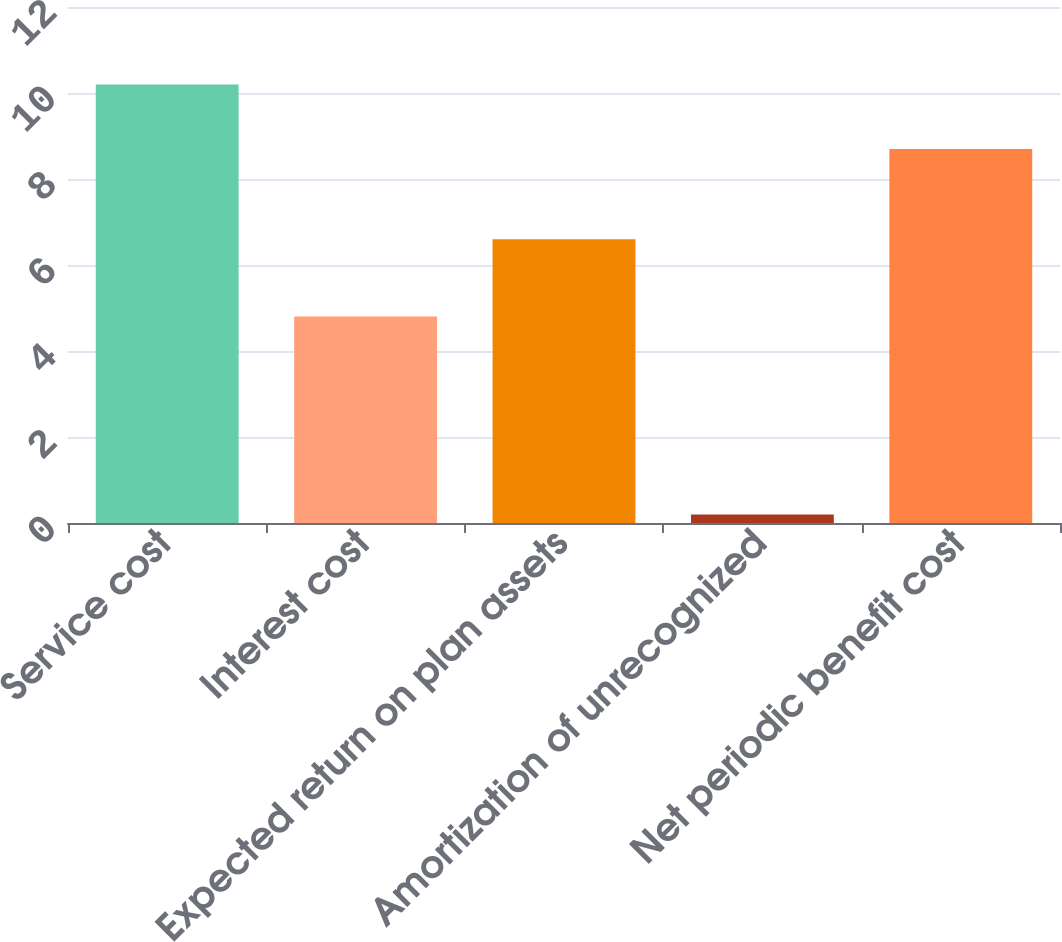Convert chart to OTSL. <chart><loc_0><loc_0><loc_500><loc_500><bar_chart><fcel>Service cost<fcel>Interest cost<fcel>Expected return on plan assets<fcel>Amortization of unrecognized<fcel>Net periodic benefit cost<nl><fcel>10.2<fcel>4.8<fcel>6.6<fcel>0.2<fcel>8.7<nl></chart> 